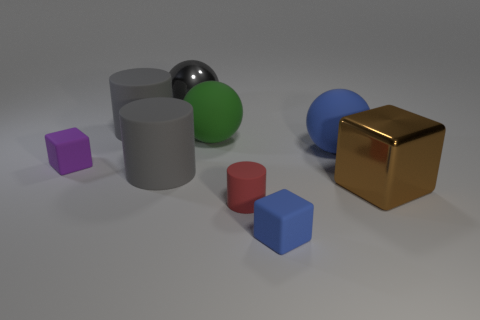There is a big metal object in front of the tiny thing that is behind the metallic block; what color is it?
Your answer should be compact. Brown. What number of big green things have the same material as the large blue thing?
Your answer should be compact. 1. How many rubber objects are either gray spheres or big red blocks?
Your response must be concise. 0. What is the material of the blue sphere that is the same size as the green rubber ball?
Your response must be concise. Rubber. Are there any small purple things that have the same material as the red cylinder?
Keep it short and to the point. Yes. What is the shape of the big metallic thing behind the rubber sphere behind the large blue sphere that is on the right side of the large green thing?
Provide a succinct answer. Sphere. There is a blue matte block; does it have the same size as the matte cylinder that is in front of the big brown metallic thing?
Provide a short and direct response. Yes. The thing that is both behind the purple object and on the right side of the tiny blue rubber thing has what shape?
Give a very brief answer. Sphere. How many large things are either purple metal balls or brown objects?
Your answer should be very brief. 1. Are there the same number of large spheres in front of the small red matte object and gray rubber cylinders in front of the big shiny ball?
Give a very brief answer. No. 